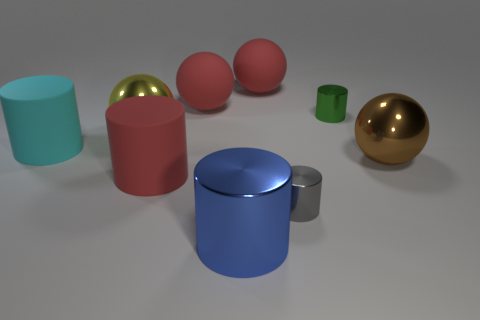Are there any metal things of the same color as the big shiny cylinder?
Make the answer very short. No. There is a brown thing on the right side of the gray metallic cylinder; what is its shape?
Your answer should be compact. Sphere. What is the color of the large metallic cylinder?
Make the answer very short. Blue. There is another tiny cylinder that is made of the same material as the small green cylinder; what color is it?
Your answer should be very brief. Gray. What number of brown objects have the same material as the tiny green cylinder?
Provide a short and direct response. 1. There is a tiny green shiny object; how many red things are on the right side of it?
Your answer should be compact. 0. Is the material of the tiny thing that is to the right of the small gray cylinder the same as the object that is to the right of the green thing?
Offer a very short reply. Yes. Are there more metallic balls behind the yellow metal object than big blue metallic cylinders that are in front of the large blue metal thing?
Provide a short and direct response. No. Is there anything else that has the same shape as the gray thing?
Ensure brevity in your answer.  Yes. There is a large object that is on the right side of the large red cylinder and in front of the brown shiny object; what is its material?
Offer a terse response. Metal. 